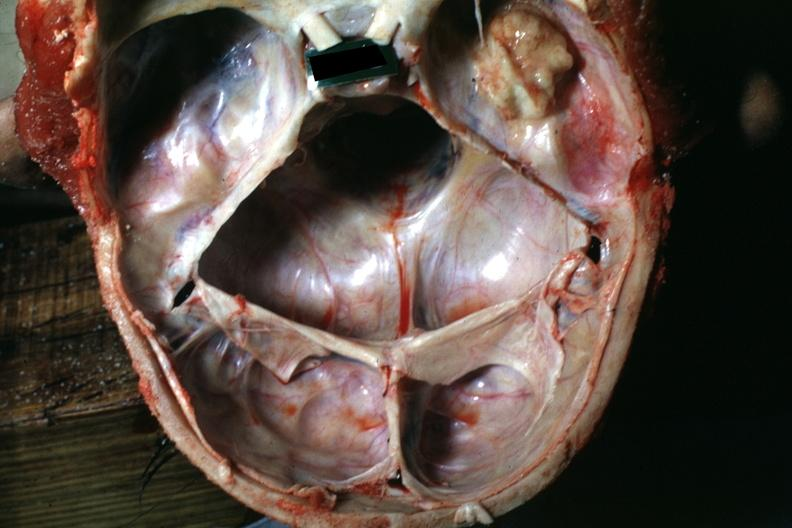does this image show large nodular osteoma in right temporal fossa?
Answer the question using a single word or phrase. Yes 